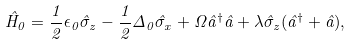<formula> <loc_0><loc_0><loc_500><loc_500>\hat { H } _ { 0 } = \frac { 1 } { 2 } \epsilon _ { 0 } \hat { \sigma } _ { z } - \frac { 1 } { 2 } \Delta _ { 0 } \hat { \sigma } _ { x } + \Omega \hat { a } ^ { \dagger } \hat { a } + \lambda \hat { \sigma } _ { z } ( \hat { a } ^ { \dagger } + \hat { a } ) ,</formula> 